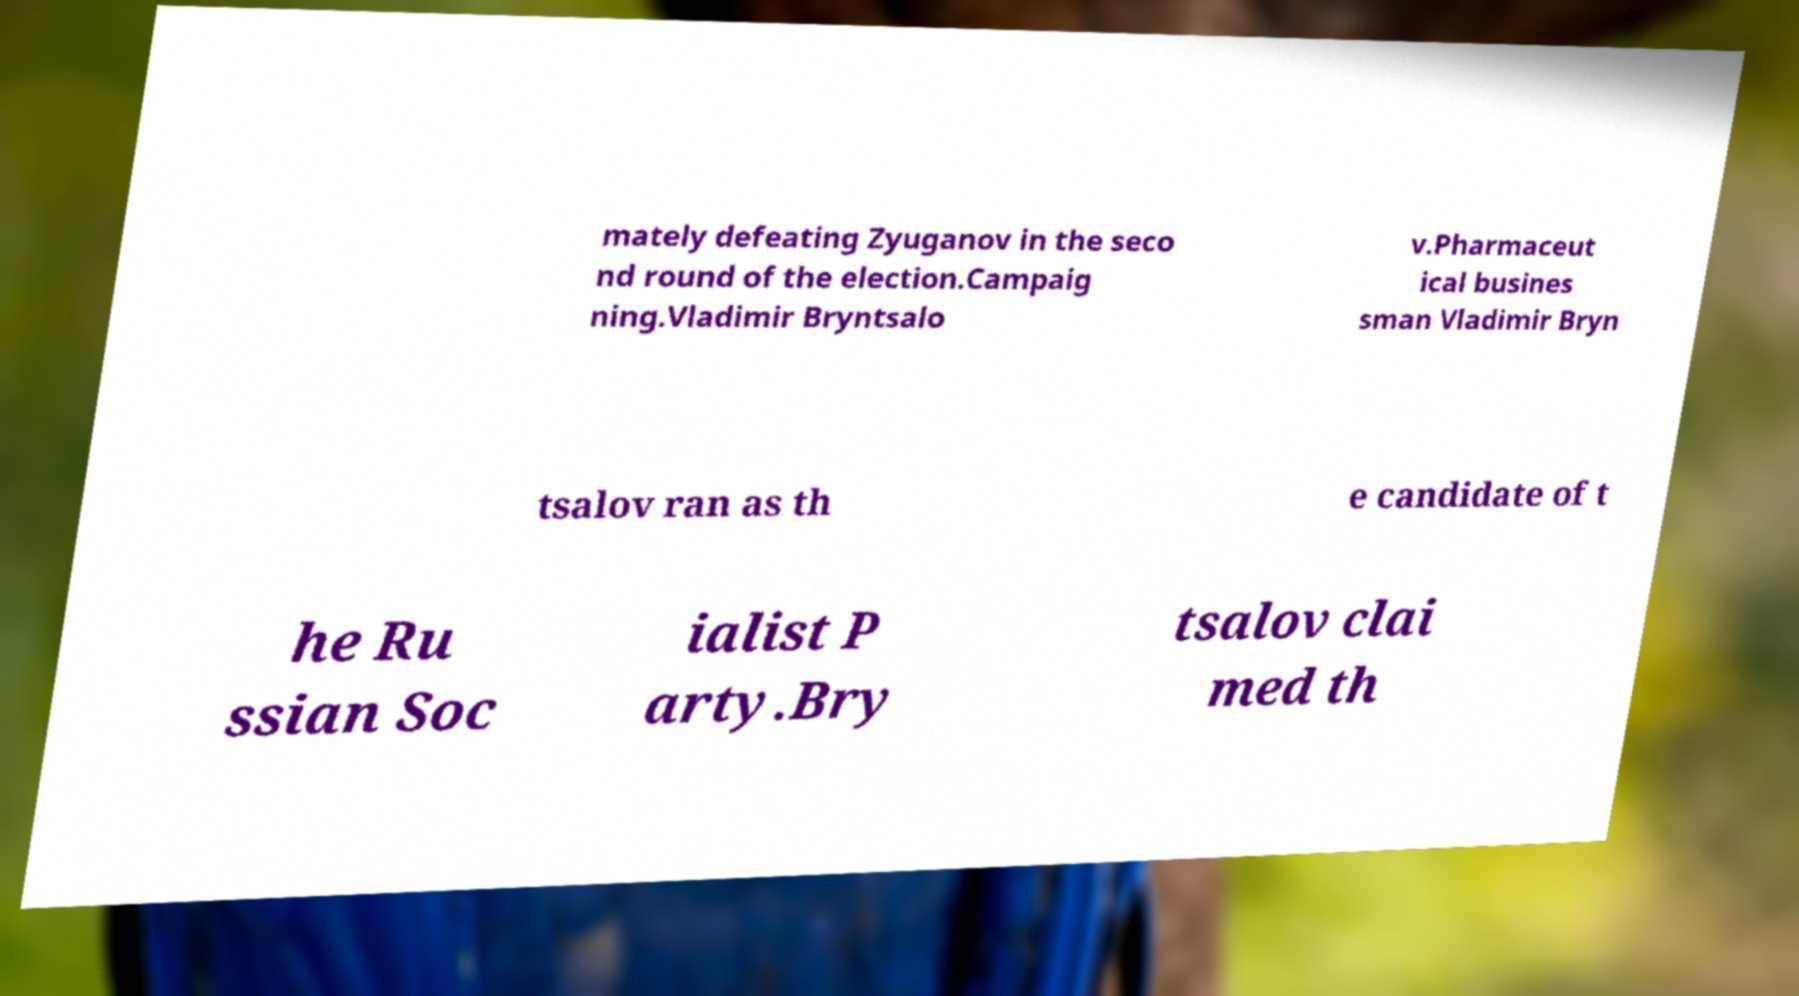Can you accurately transcribe the text from the provided image for me? mately defeating Zyuganov in the seco nd round of the election.Campaig ning.Vladimir Bryntsalo v.Pharmaceut ical busines sman Vladimir Bryn tsalov ran as th e candidate of t he Ru ssian Soc ialist P arty.Bry tsalov clai med th 